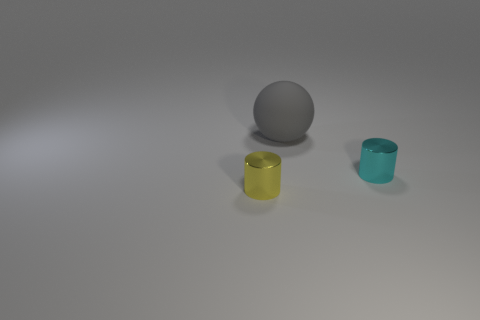There is a tiny metallic cylinder that is left of the cyan metallic object; what is its color?
Provide a short and direct response. Yellow. Do the cyan shiny object and the gray thing have the same shape?
Give a very brief answer. No. There is a thing that is in front of the big ball and left of the cyan object; what is its color?
Keep it short and to the point. Yellow. There is a metal cylinder that is on the left side of the gray thing; is it the same size as the object that is behind the cyan metal object?
Offer a terse response. No. What number of objects are tiny metallic objects behind the tiny yellow metal object or spheres?
Make the answer very short. 2. What is the material of the yellow cylinder?
Provide a short and direct response. Metal. Do the gray thing and the yellow object have the same size?
Give a very brief answer. No. How many cylinders are large gray rubber objects or small cyan things?
Your answer should be very brief. 1. There is a metal cylinder that is to the left of the large matte ball left of the cyan cylinder; what is its color?
Give a very brief answer. Yellow. Are there fewer yellow objects that are in front of the yellow shiny object than tiny cyan metallic cylinders right of the tiny cyan cylinder?
Your answer should be compact. No. 